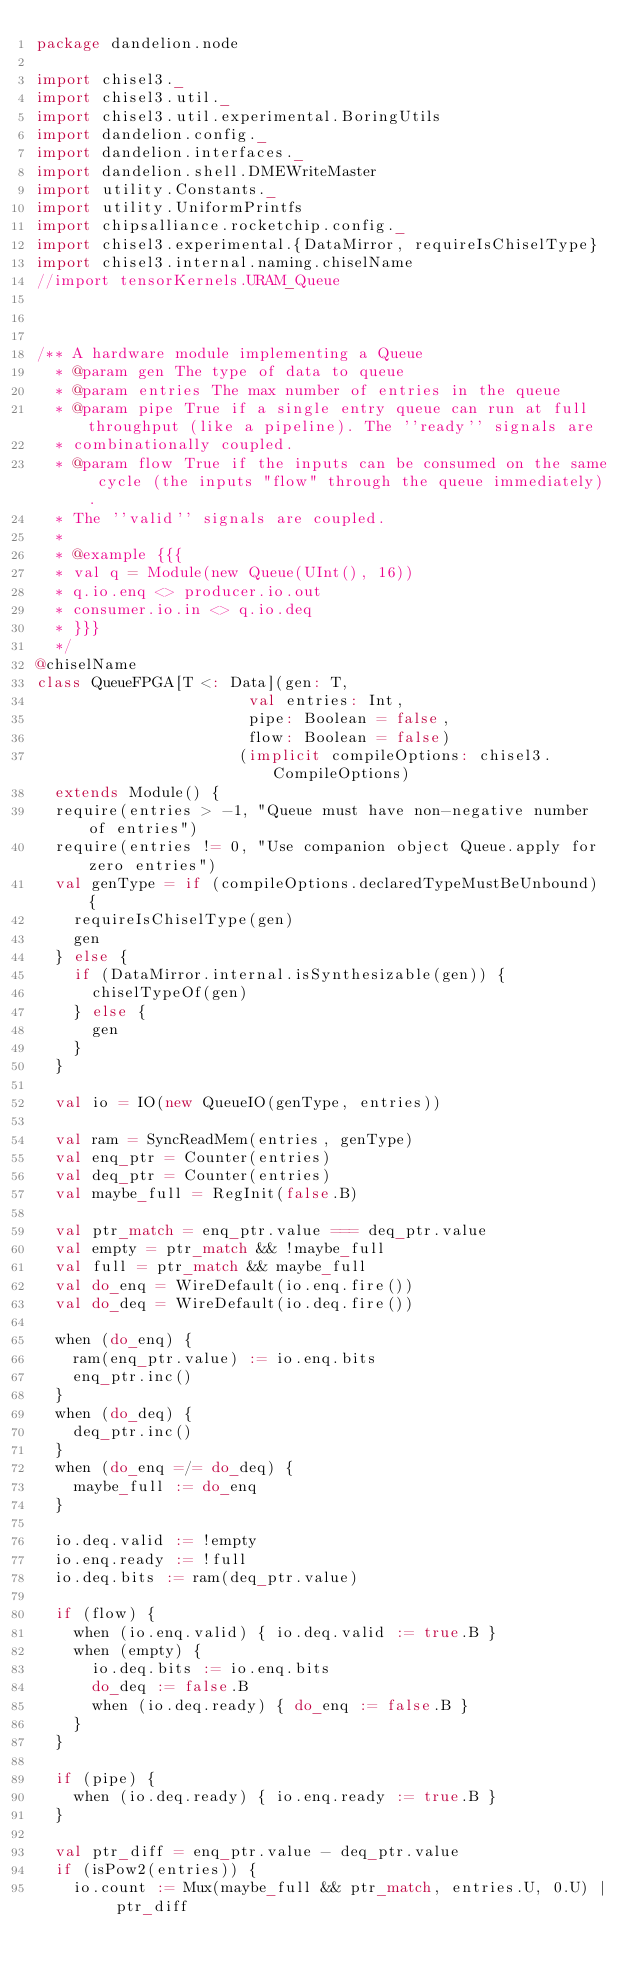<code> <loc_0><loc_0><loc_500><loc_500><_Scala_>package dandelion.node

import chisel3._
import chisel3.util._
import chisel3.util.experimental.BoringUtils
import dandelion.config._
import dandelion.interfaces._
import dandelion.shell.DMEWriteMaster
import utility.Constants._
import utility.UniformPrintfs
import chipsalliance.rocketchip.config._
import chisel3.experimental.{DataMirror, requireIsChiselType}
import chisel3.internal.naming.chiselName
//import tensorKernels.URAM_Queue



/** A hardware module implementing a Queue
  * @param gen The type of data to queue
  * @param entries The max number of entries in the queue
  * @param pipe True if a single entry queue can run at full throughput (like a pipeline). The ''ready'' signals are
  * combinationally coupled.
  * @param flow True if the inputs can be consumed on the same cycle (the inputs "flow" through the queue immediately).
  * The ''valid'' signals are coupled.
  *
  * @example {{{
  * val q = Module(new Queue(UInt(), 16))
  * q.io.enq <> producer.io.out
  * consumer.io.in <> q.io.deq
  * }}}
  */
@chiselName
class QueueFPGA[T <: Data](gen: T,
                       val entries: Int,
                       pipe: Boolean = false,
                       flow: Boolean = false)
                      (implicit compileOptions: chisel3.CompileOptions)
  extends Module() {
  require(entries > -1, "Queue must have non-negative number of entries")
  require(entries != 0, "Use companion object Queue.apply for zero entries")
  val genType = if (compileOptions.declaredTypeMustBeUnbound) {
    requireIsChiselType(gen)
    gen
  } else {
    if (DataMirror.internal.isSynthesizable(gen)) {
      chiselTypeOf(gen)
    } else {
      gen
    }
  }

  val io = IO(new QueueIO(genType, entries))

  val ram = SyncReadMem(entries, genType)
  val enq_ptr = Counter(entries)
  val deq_ptr = Counter(entries)
  val maybe_full = RegInit(false.B)

  val ptr_match = enq_ptr.value === deq_ptr.value
  val empty = ptr_match && !maybe_full
  val full = ptr_match && maybe_full
  val do_enq = WireDefault(io.enq.fire())
  val do_deq = WireDefault(io.deq.fire())

  when (do_enq) {
    ram(enq_ptr.value) := io.enq.bits
    enq_ptr.inc()
  }
  when (do_deq) {
    deq_ptr.inc()
  }
  when (do_enq =/= do_deq) {
    maybe_full := do_enq
  }

  io.deq.valid := !empty
  io.enq.ready := !full
  io.deq.bits := ram(deq_ptr.value)

  if (flow) {
    when (io.enq.valid) { io.deq.valid := true.B }
    when (empty) {
      io.deq.bits := io.enq.bits
      do_deq := false.B
      when (io.deq.ready) { do_enq := false.B }
    }
  }

  if (pipe) {
    when (io.deq.ready) { io.enq.ready := true.B }
  }

  val ptr_diff = enq_ptr.value - deq_ptr.value
  if (isPow2(entries)) {
    io.count := Mux(maybe_full && ptr_match, entries.U, 0.U) | ptr_diff</code> 